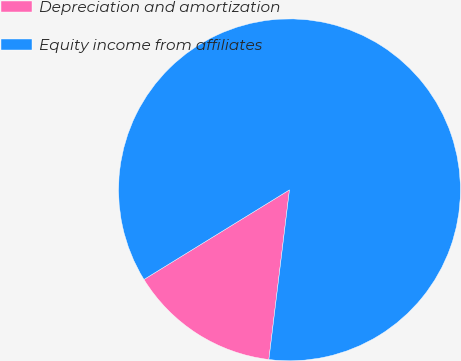Convert chart to OTSL. <chart><loc_0><loc_0><loc_500><loc_500><pie_chart><fcel>Depreciation and amortization<fcel>Equity income from affiliates<nl><fcel>14.29%<fcel>85.71%<nl></chart> 